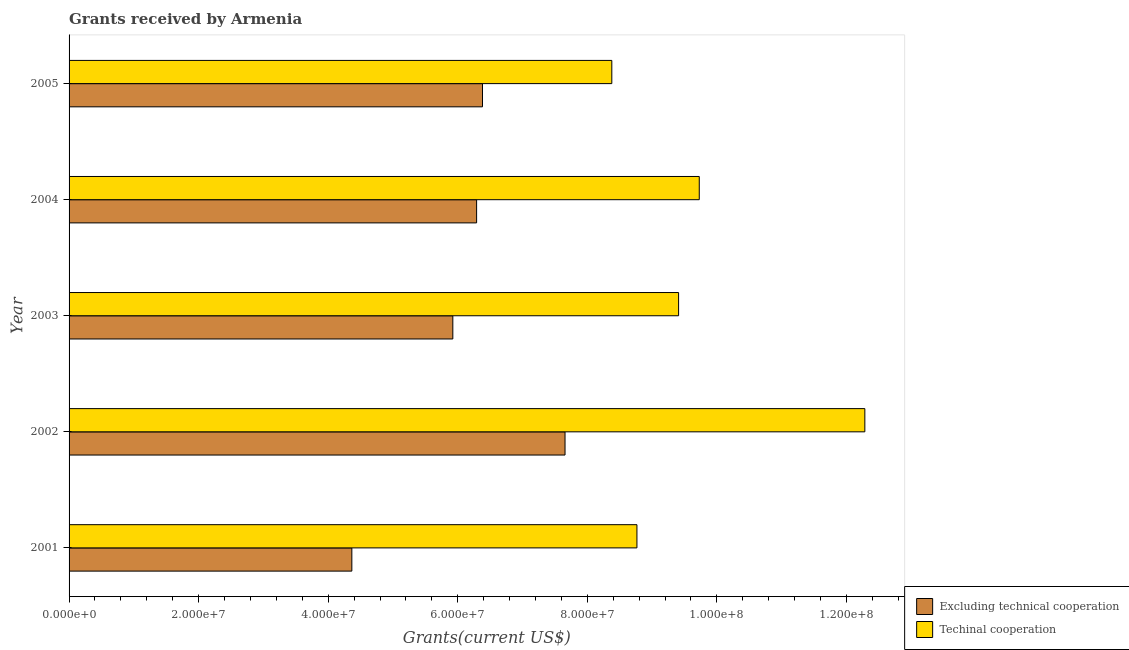How many different coloured bars are there?
Give a very brief answer. 2. How many groups of bars are there?
Make the answer very short. 5. Are the number of bars per tick equal to the number of legend labels?
Offer a terse response. Yes. Are the number of bars on each tick of the Y-axis equal?
Offer a very short reply. Yes. How many bars are there on the 5th tick from the bottom?
Provide a succinct answer. 2. What is the label of the 3rd group of bars from the top?
Provide a short and direct response. 2003. In how many cases, is the number of bars for a given year not equal to the number of legend labels?
Make the answer very short. 0. What is the amount of grants received(excluding technical cooperation) in 2004?
Provide a short and direct response. 6.29e+07. Across all years, what is the maximum amount of grants received(including technical cooperation)?
Keep it short and to the point. 1.23e+08. Across all years, what is the minimum amount of grants received(excluding technical cooperation)?
Offer a very short reply. 4.36e+07. In which year was the amount of grants received(including technical cooperation) maximum?
Your response must be concise. 2002. In which year was the amount of grants received(including technical cooperation) minimum?
Ensure brevity in your answer.  2005. What is the total amount of grants received(excluding technical cooperation) in the graph?
Provide a succinct answer. 3.06e+08. What is the difference between the amount of grants received(excluding technical cooperation) in 2001 and that in 2004?
Offer a terse response. -1.93e+07. What is the difference between the amount of grants received(including technical cooperation) in 2002 and the amount of grants received(excluding technical cooperation) in 2003?
Offer a very short reply. 6.36e+07. What is the average amount of grants received(including technical cooperation) per year?
Offer a terse response. 9.71e+07. In the year 2001, what is the difference between the amount of grants received(including technical cooperation) and amount of grants received(excluding technical cooperation)?
Give a very brief answer. 4.40e+07. What is the ratio of the amount of grants received(excluding technical cooperation) in 2002 to that in 2005?
Make the answer very short. 1.2. Is the amount of grants received(including technical cooperation) in 2004 less than that in 2005?
Provide a short and direct response. No. Is the difference between the amount of grants received(including technical cooperation) in 2001 and 2003 greater than the difference between the amount of grants received(excluding technical cooperation) in 2001 and 2003?
Offer a terse response. Yes. What is the difference between the highest and the second highest amount of grants received(excluding technical cooperation)?
Make the answer very short. 1.27e+07. What is the difference between the highest and the lowest amount of grants received(including technical cooperation)?
Your answer should be very brief. 3.91e+07. Is the sum of the amount of grants received(including technical cooperation) in 2001 and 2004 greater than the maximum amount of grants received(excluding technical cooperation) across all years?
Offer a very short reply. Yes. What does the 2nd bar from the top in 2005 represents?
Your answer should be compact. Excluding technical cooperation. What does the 2nd bar from the bottom in 2002 represents?
Offer a very short reply. Techinal cooperation. How many bars are there?
Make the answer very short. 10. How many years are there in the graph?
Provide a short and direct response. 5. What is the difference between two consecutive major ticks on the X-axis?
Provide a short and direct response. 2.00e+07. Are the values on the major ticks of X-axis written in scientific E-notation?
Offer a very short reply. Yes. Where does the legend appear in the graph?
Make the answer very short. Bottom right. What is the title of the graph?
Make the answer very short. Grants received by Armenia. What is the label or title of the X-axis?
Offer a terse response. Grants(current US$). What is the label or title of the Y-axis?
Make the answer very short. Year. What is the Grants(current US$) in Excluding technical cooperation in 2001?
Offer a very short reply. 4.36e+07. What is the Grants(current US$) in Techinal cooperation in 2001?
Make the answer very short. 8.77e+07. What is the Grants(current US$) of Excluding technical cooperation in 2002?
Your answer should be compact. 7.66e+07. What is the Grants(current US$) of Techinal cooperation in 2002?
Offer a terse response. 1.23e+08. What is the Grants(current US$) in Excluding technical cooperation in 2003?
Offer a very short reply. 5.92e+07. What is the Grants(current US$) in Techinal cooperation in 2003?
Your response must be concise. 9.41e+07. What is the Grants(current US$) in Excluding technical cooperation in 2004?
Provide a short and direct response. 6.29e+07. What is the Grants(current US$) in Techinal cooperation in 2004?
Your answer should be very brief. 9.73e+07. What is the Grants(current US$) in Excluding technical cooperation in 2005?
Your answer should be very brief. 6.38e+07. What is the Grants(current US$) in Techinal cooperation in 2005?
Offer a terse response. 8.38e+07. Across all years, what is the maximum Grants(current US$) in Excluding technical cooperation?
Your response must be concise. 7.66e+07. Across all years, what is the maximum Grants(current US$) in Techinal cooperation?
Provide a short and direct response. 1.23e+08. Across all years, what is the minimum Grants(current US$) in Excluding technical cooperation?
Make the answer very short. 4.36e+07. Across all years, what is the minimum Grants(current US$) in Techinal cooperation?
Provide a succinct answer. 8.38e+07. What is the total Grants(current US$) in Excluding technical cooperation in the graph?
Offer a terse response. 3.06e+08. What is the total Grants(current US$) of Techinal cooperation in the graph?
Offer a terse response. 4.86e+08. What is the difference between the Grants(current US$) of Excluding technical cooperation in 2001 and that in 2002?
Your answer should be very brief. -3.29e+07. What is the difference between the Grants(current US$) of Techinal cooperation in 2001 and that in 2002?
Your response must be concise. -3.52e+07. What is the difference between the Grants(current US$) in Excluding technical cooperation in 2001 and that in 2003?
Offer a terse response. -1.56e+07. What is the difference between the Grants(current US$) of Techinal cooperation in 2001 and that in 2003?
Ensure brevity in your answer.  -6.43e+06. What is the difference between the Grants(current US$) in Excluding technical cooperation in 2001 and that in 2004?
Your answer should be very brief. -1.93e+07. What is the difference between the Grants(current US$) in Techinal cooperation in 2001 and that in 2004?
Keep it short and to the point. -9.62e+06. What is the difference between the Grants(current US$) of Excluding technical cooperation in 2001 and that in 2005?
Offer a very short reply. -2.02e+07. What is the difference between the Grants(current US$) in Techinal cooperation in 2001 and that in 2005?
Your response must be concise. 3.88e+06. What is the difference between the Grants(current US$) in Excluding technical cooperation in 2002 and that in 2003?
Your answer should be very brief. 1.73e+07. What is the difference between the Grants(current US$) in Techinal cooperation in 2002 and that in 2003?
Your answer should be compact. 2.88e+07. What is the difference between the Grants(current US$) in Excluding technical cooperation in 2002 and that in 2004?
Keep it short and to the point. 1.36e+07. What is the difference between the Grants(current US$) in Techinal cooperation in 2002 and that in 2004?
Keep it short and to the point. 2.56e+07. What is the difference between the Grants(current US$) of Excluding technical cooperation in 2002 and that in 2005?
Provide a succinct answer. 1.27e+07. What is the difference between the Grants(current US$) of Techinal cooperation in 2002 and that in 2005?
Your answer should be compact. 3.91e+07. What is the difference between the Grants(current US$) of Excluding technical cooperation in 2003 and that in 2004?
Ensure brevity in your answer.  -3.67e+06. What is the difference between the Grants(current US$) in Techinal cooperation in 2003 and that in 2004?
Your response must be concise. -3.19e+06. What is the difference between the Grants(current US$) in Excluding technical cooperation in 2003 and that in 2005?
Provide a short and direct response. -4.58e+06. What is the difference between the Grants(current US$) of Techinal cooperation in 2003 and that in 2005?
Ensure brevity in your answer.  1.03e+07. What is the difference between the Grants(current US$) in Excluding technical cooperation in 2004 and that in 2005?
Your answer should be very brief. -9.10e+05. What is the difference between the Grants(current US$) of Techinal cooperation in 2004 and that in 2005?
Your response must be concise. 1.35e+07. What is the difference between the Grants(current US$) in Excluding technical cooperation in 2001 and the Grants(current US$) in Techinal cooperation in 2002?
Provide a succinct answer. -7.92e+07. What is the difference between the Grants(current US$) of Excluding technical cooperation in 2001 and the Grants(current US$) of Techinal cooperation in 2003?
Offer a very short reply. -5.04e+07. What is the difference between the Grants(current US$) in Excluding technical cooperation in 2001 and the Grants(current US$) in Techinal cooperation in 2004?
Keep it short and to the point. -5.36e+07. What is the difference between the Grants(current US$) of Excluding technical cooperation in 2001 and the Grants(current US$) of Techinal cooperation in 2005?
Your answer should be very brief. -4.01e+07. What is the difference between the Grants(current US$) in Excluding technical cooperation in 2002 and the Grants(current US$) in Techinal cooperation in 2003?
Make the answer very short. -1.75e+07. What is the difference between the Grants(current US$) of Excluding technical cooperation in 2002 and the Grants(current US$) of Techinal cooperation in 2004?
Your answer should be compact. -2.07e+07. What is the difference between the Grants(current US$) of Excluding technical cooperation in 2002 and the Grants(current US$) of Techinal cooperation in 2005?
Your answer should be very brief. -7.22e+06. What is the difference between the Grants(current US$) in Excluding technical cooperation in 2003 and the Grants(current US$) in Techinal cooperation in 2004?
Give a very brief answer. -3.80e+07. What is the difference between the Grants(current US$) of Excluding technical cooperation in 2003 and the Grants(current US$) of Techinal cooperation in 2005?
Offer a very short reply. -2.45e+07. What is the difference between the Grants(current US$) in Excluding technical cooperation in 2004 and the Grants(current US$) in Techinal cooperation in 2005?
Make the answer very short. -2.09e+07. What is the average Grants(current US$) in Excluding technical cooperation per year?
Your answer should be compact. 6.12e+07. What is the average Grants(current US$) in Techinal cooperation per year?
Make the answer very short. 9.71e+07. In the year 2001, what is the difference between the Grants(current US$) in Excluding technical cooperation and Grants(current US$) in Techinal cooperation?
Give a very brief answer. -4.40e+07. In the year 2002, what is the difference between the Grants(current US$) in Excluding technical cooperation and Grants(current US$) in Techinal cooperation?
Your answer should be compact. -4.63e+07. In the year 2003, what is the difference between the Grants(current US$) of Excluding technical cooperation and Grants(current US$) of Techinal cooperation?
Your answer should be compact. -3.48e+07. In the year 2004, what is the difference between the Grants(current US$) in Excluding technical cooperation and Grants(current US$) in Techinal cooperation?
Provide a short and direct response. -3.44e+07. In the year 2005, what is the difference between the Grants(current US$) in Excluding technical cooperation and Grants(current US$) in Techinal cooperation?
Your response must be concise. -2.00e+07. What is the ratio of the Grants(current US$) in Excluding technical cooperation in 2001 to that in 2002?
Your response must be concise. 0.57. What is the ratio of the Grants(current US$) in Techinal cooperation in 2001 to that in 2002?
Your answer should be very brief. 0.71. What is the ratio of the Grants(current US$) in Excluding technical cooperation in 2001 to that in 2003?
Make the answer very short. 0.74. What is the ratio of the Grants(current US$) of Techinal cooperation in 2001 to that in 2003?
Your response must be concise. 0.93. What is the ratio of the Grants(current US$) of Excluding technical cooperation in 2001 to that in 2004?
Offer a terse response. 0.69. What is the ratio of the Grants(current US$) of Techinal cooperation in 2001 to that in 2004?
Provide a succinct answer. 0.9. What is the ratio of the Grants(current US$) in Excluding technical cooperation in 2001 to that in 2005?
Your answer should be very brief. 0.68. What is the ratio of the Grants(current US$) in Techinal cooperation in 2001 to that in 2005?
Your answer should be compact. 1.05. What is the ratio of the Grants(current US$) of Excluding technical cooperation in 2002 to that in 2003?
Your response must be concise. 1.29. What is the ratio of the Grants(current US$) of Techinal cooperation in 2002 to that in 2003?
Provide a short and direct response. 1.31. What is the ratio of the Grants(current US$) in Excluding technical cooperation in 2002 to that in 2004?
Provide a short and direct response. 1.22. What is the ratio of the Grants(current US$) of Techinal cooperation in 2002 to that in 2004?
Your answer should be compact. 1.26. What is the ratio of the Grants(current US$) of Excluding technical cooperation in 2002 to that in 2005?
Your answer should be very brief. 1.2. What is the ratio of the Grants(current US$) of Techinal cooperation in 2002 to that in 2005?
Provide a short and direct response. 1.47. What is the ratio of the Grants(current US$) in Excluding technical cooperation in 2003 to that in 2004?
Make the answer very short. 0.94. What is the ratio of the Grants(current US$) in Techinal cooperation in 2003 to that in 2004?
Make the answer very short. 0.97. What is the ratio of the Grants(current US$) of Excluding technical cooperation in 2003 to that in 2005?
Offer a terse response. 0.93. What is the ratio of the Grants(current US$) of Techinal cooperation in 2003 to that in 2005?
Provide a succinct answer. 1.12. What is the ratio of the Grants(current US$) of Excluding technical cooperation in 2004 to that in 2005?
Provide a succinct answer. 0.99. What is the ratio of the Grants(current US$) of Techinal cooperation in 2004 to that in 2005?
Your answer should be very brief. 1.16. What is the difference between the highest and the second highest Grants(current US$) in Excluding technical cooperation?
Your answer should be very brief. 1.27e+07. What is the difference between the highest and the second highest Grants(current US$) in Techinal cooperation?
Your answer should be very brief. 2.56e+07. What is the difference between the highest and the lowest Grants(current US$) in Excluding technical cooperation?
Keep it short and to the point. 3.29e+07. What is the difference between the highest and the lowest Grants(current US$) in Techinal cooperation?
Make the answer very short. 3.91e+07. 